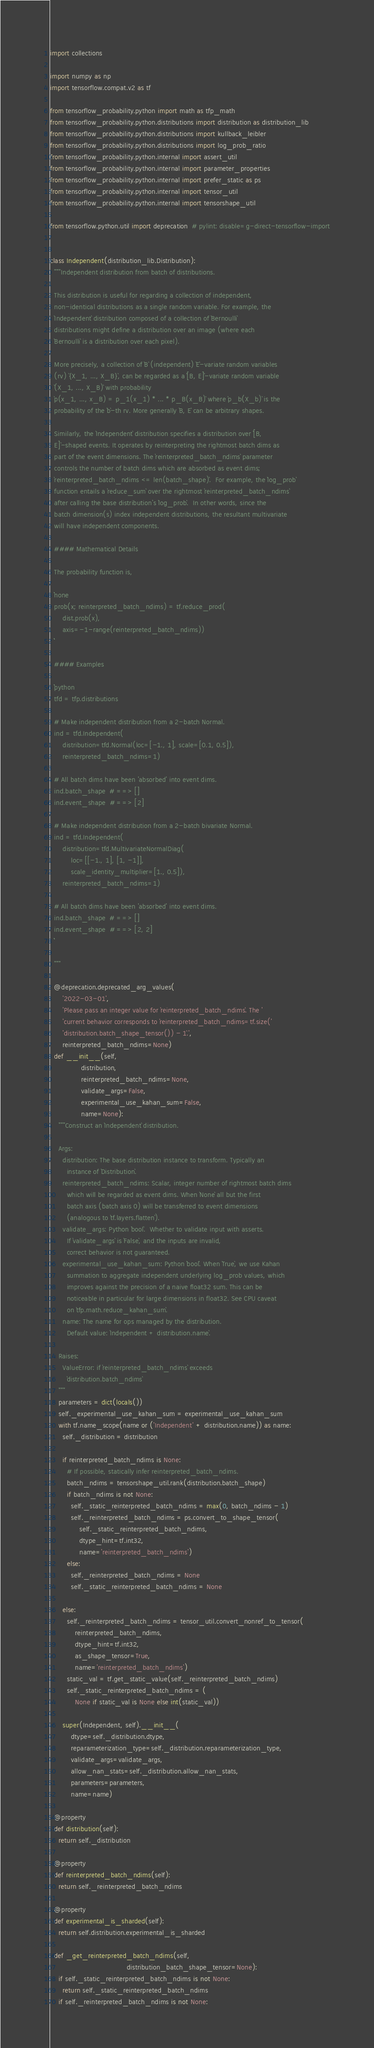Convert code to text. <code><loc_0><loc_0><loc_500><loc_500><_Python_>
import collections

import numpy as np
import tensorflow.compat.v2 as tf

from tensorflow_probability.python import math as tfp_math
from tensorflow_probability.python.distributions import distribution as distribution_lib
from tensorflow_probability.python.distributions import kullback_leibler
from tensorflow_probability.python.distributions import log_prob_ratio
from tensorflow_probability.python.internal import assert_util
from tensorflow_probability.python.internal import parameter_properties
from tensorflow_probability.python.internal import prefer_static as ps
from tensorflow_probability.python.internal import tensor_util
from tensorflow_probability.python.internal import tensorshape_util

from tensorflow.python.util import deprecation  # pylint: disable=g-direct-tensorflow-import


class Independent(distribution_lib.Distribution):
  """Independent distribution from batch of distributions.

  This distribution is useful for regarding a collection of independent,
  non-identical distributions as a single random variable. For example, the
  `Independent` distribution composed of a collection of `Bernoulli`
  distributions might define a distribution over an image (where each
  `Bernoulli` is a distribution over each pixel).

  More precisely, a collection of `B` (independent) `E`-variate random variables
  (rv) `{X_1, ..., X_B}`, can be regarded as a `[B, E]`-variate random variable
  `(X_1, ..., X_B)` with probability
  `p(x_1, ..., x_B) = p_1(x_1) * ... * p_B(x_B)` where `p_b(X_b)` is the
  probability of the `b`-th rv. More generally `B, E` can be arbitrary shapes.

  Similarly, the `Independent` distribution specifies a distribution over `[B,
  E]`-shaped events. It operates by reinterpreting the rightmost batch dims as
  part of the event dimensions. The `reinterpreted_batch_ndims` parameter
  controls the number of batch dims which are absorbed as event dims;
  `reinterpreted_batch_ndims <= len(batch_shape)`.  For example, the `log_prob`
  function entails a `reduce_sum` over the rightmost `reinterpreted_batch_ndims`
  after calling the base distribution's `log_prob`.  In other words, since the
  batch dimension(s) index independent distributions, the resultant multivariate
  will have independent components.

  #### Mathematical Details

  The probability function is,

  ```none
  prob(x; reinterpreted_batch_ndims) = tf.reduce_prod(
      dist.prob(x),
      axis=-1-range(reinterpreted_batch_ndims))
  ```

  #### Examples

  ```python
  tfd = tfp.distributions

  # Make independent distribution from a 2-batch Normal.
  ind = tfd.Independent(
      distribution=tfd.Normal(loc=[-1., 1], scale=[0.1, 0.5]),
      reinterpreted_batch_ndims=1)

  # All batch dims have been 'absorbed' into event dims.
  ind.batch_shape  # ==> []
  ind.event_shape  # ==> [2]

  # Make independent distribution from a 2-batch bivariate Normal.
  ind = tfd.Independent(
      distribution=tfd.MultivariateNormalDiag(
          loc=[[-1., 1], [1, -1]],
          scale_identity_multiplier=[1., 0.5]),
      reinterpreted_batch_ndims=1)

  # All batch dims have been 'absorbed' into event dims.
  ind.batch_shape  # ==> []
  ind.event_shape  # ==> [2, 2]
  ```

  """

  @deprecation.deprecated_arg_values(
      '2022-03-01',
      'Please pass an integer value for `reinterpreted_batch_ndims`. The '
      'current behavior corresponds to `reinterpreted_batch_ndims=tf.size('
      'distribution.batch_shape_tensor()) - 1`.',
      reinterpreted_batch_ndims=None)
  def __init__(self,
               distribution,
               reinterpreted_batch_ndims=None,
               validate_args=False,
               experimental_use_kahan_sum=False,
               name=None):
    """Construct an `Independent` distribution.

    Args:
      distribution: The base distribution instance to transform. Typically an
        instance of `Distribution`.
      reinterpreted_batch_ndims: Scalar, integer number of rightmost batch dims
        which will be regarded as event dims. When `None` all but the first
        batch axis (batch axis 0) will be transferred to event dimensions
        (analogous to `tf.layers.flatten`).
      validate_args: Python `bool`.  Whether to validate input with asserts.
        If `validate_args` is `False`, and the inputs are invalid,
        correct behavior is not guaranteed.
      experimental_use_kahan_sum: Python `bool`. When `True`, we use Kahan
        summation to aggregate independent underlying log_prob values, which
        improves against the precision of a naive float32 sum. This can be
        noticeable in particular for large dimensions in float32. See CPU caveat
        on `tfp.math.reduce_kahan_sum`.
      name: The name for ops managed by the distribution.
        Default value: `Independent + distribution.name`.

    Raises:
      ValueError: if `reinterpreted_batch_ndims` exceeds
        `distribution.batch_ndims`
    """
    parameters = dict(locals())
    self._experimental_use_kahan_sum = experimental_use_kahan_sum
    with tf.name_scope(name or ('Independent' + distribution.name)) as name:
      self._distribution = distribution

      if reinterpreted_batch_ndims is None:
        # If possible, statically infer reinterpreted_batch_ndims.
        batch_ndims = tensorshape_util.rank(distribution.batch_shape)
        if batch_ndims is not None:
          self._static_reinterpreted_batch_ndims = max(0, batch_ndims - 1)
          self._reinterpreted_batch_ndims = ps.convert_to_shape_tensor(
              self._static_reinterpreted_batch_ndims,
              dtype_hint=tf.int32,
              name='reinterpreted_batch_ndims')
        else:
          self._reinterpreted_batch_ndims = None
          self._static_reinterpreted_batch_ndims = None

      else:
        self._reinterpreted_batch_ndims = tensor_util.convert_nonref_to_tensor(
            reinterpreted_batch_ndims,
            dtype_hint=tf.int32,
            as_shape_tensor=True,
            name='reinterpreted_batch_ndims')
        static_val = tf.get_static_value(self._reinterpreted_batch_ndims)
        self._static_reinterpreted_batch_ndims = (
            None if static_val is None else int(static_val))

      super(Independent, self).__init__(
          dtype=self._distribution.dtype,
          reparameterization_type=self._distribution.reparameterization_type,
          validate_args=validate_args,
          allow_nan_stats=self._distribution.allow_nan_stats,
          parameters=parameters,
          name=name)

  @property
  def distribution(self):
    return self._distribution

  @property
  def reinterpreted_batch_ndims(self):
    return self._reinterpreted_batch_ndims

  @property
  def experimental_is_sharded(self):
    return self.distribution.experimental_is_sharded

  def _get_reinterpreted_batch_ndims(self,
                                     distribution_batch_shape_tensor=None):
    if self._static_reinterpreted_batch_ndims is not None:
      return self._static_reinterpreted_batch_ndims
    if self._reinterpreted_batch_ndims is not None:</code> 